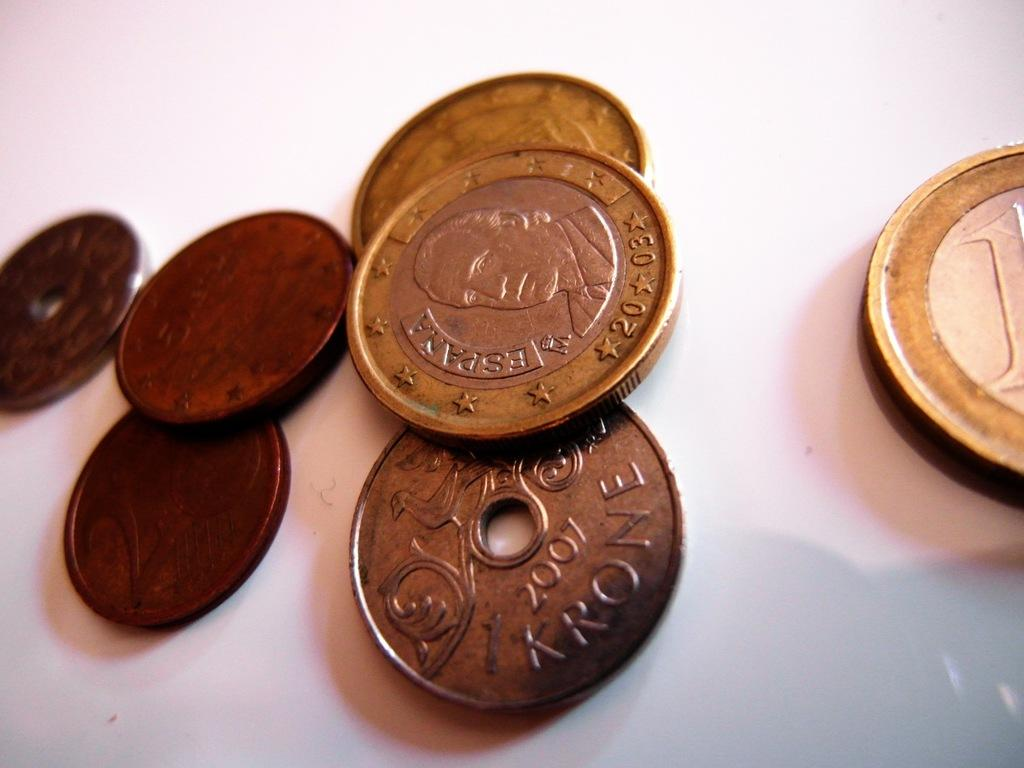<image>
Give a short and clear explanation of the subsequent image. A number of coins from different countries including Spain 